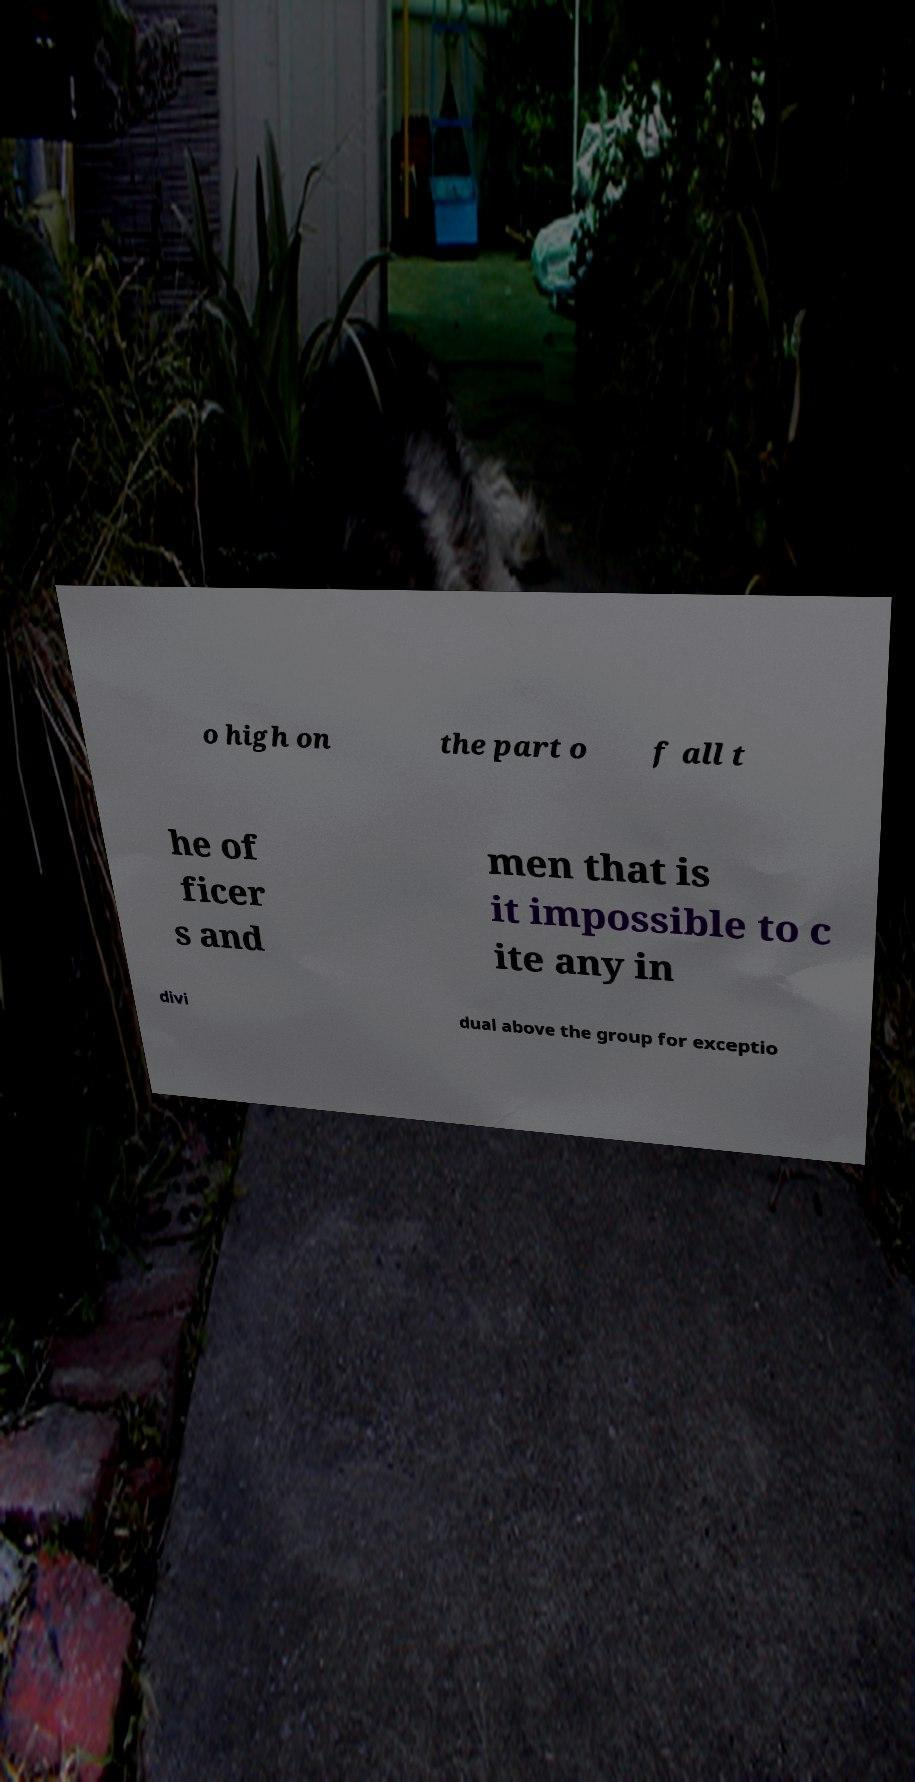Could you assist in decoding the text presented in this image and type it out clearly? o high on the part o f all t he of ficer s and men that is it impossible to c ite any in divi dual above the group for exceptio 